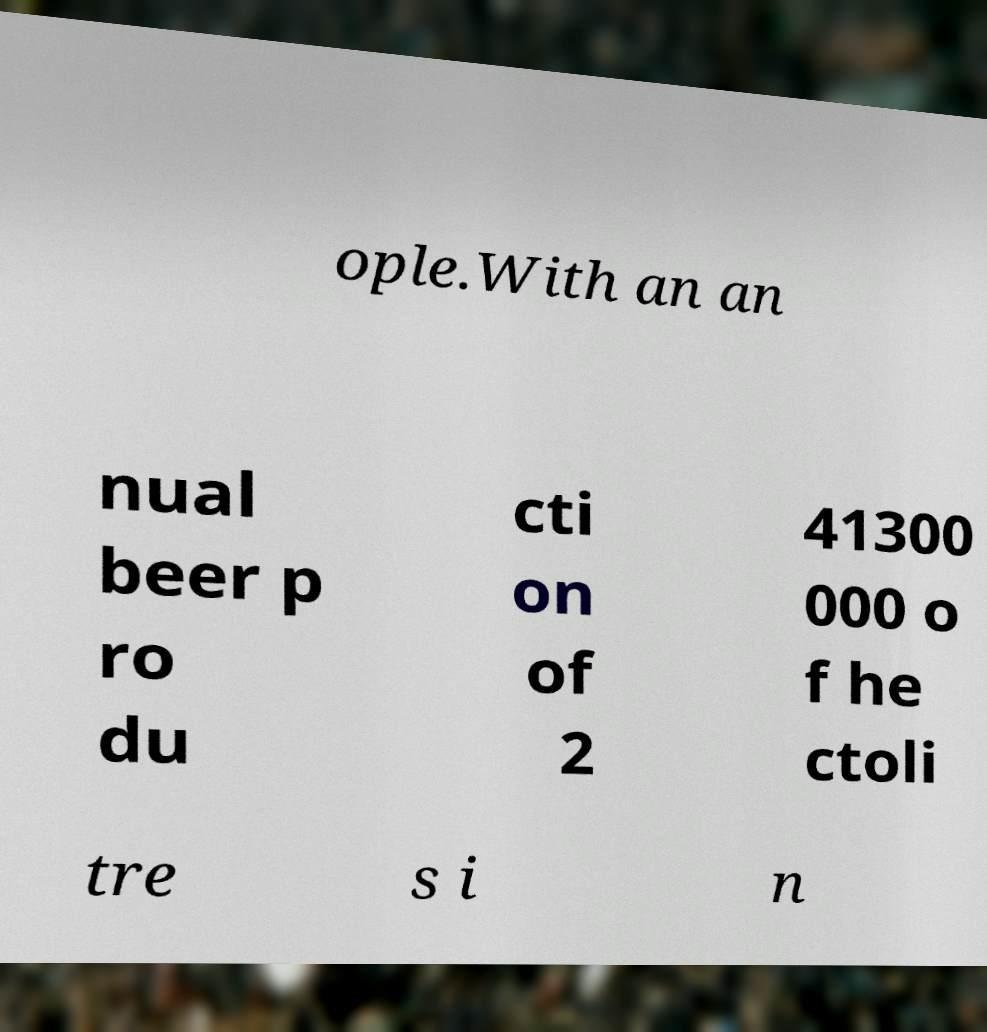There's text embedded in this image that I need extracted. Can you transcribe it verbatim? ople.With an an nual beer p ro du cti on of 2 41300 000 o f he ctoli tre s i n 